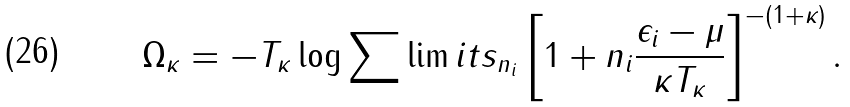Convert formula to latex. <formula><loc_0><loc_0><loc_500><loc_500>\Omega _ { \kappa } = - T _ { \kappa } \log \sum \lim i t s _ { n _ { i } } \left [ 1 + n _ { i } \frac { \epsilon _ { i } - \mu } { \kappa T _ { \kappa } } \right ] ^ { - ( 1 + \kappa ) } .</formula> 